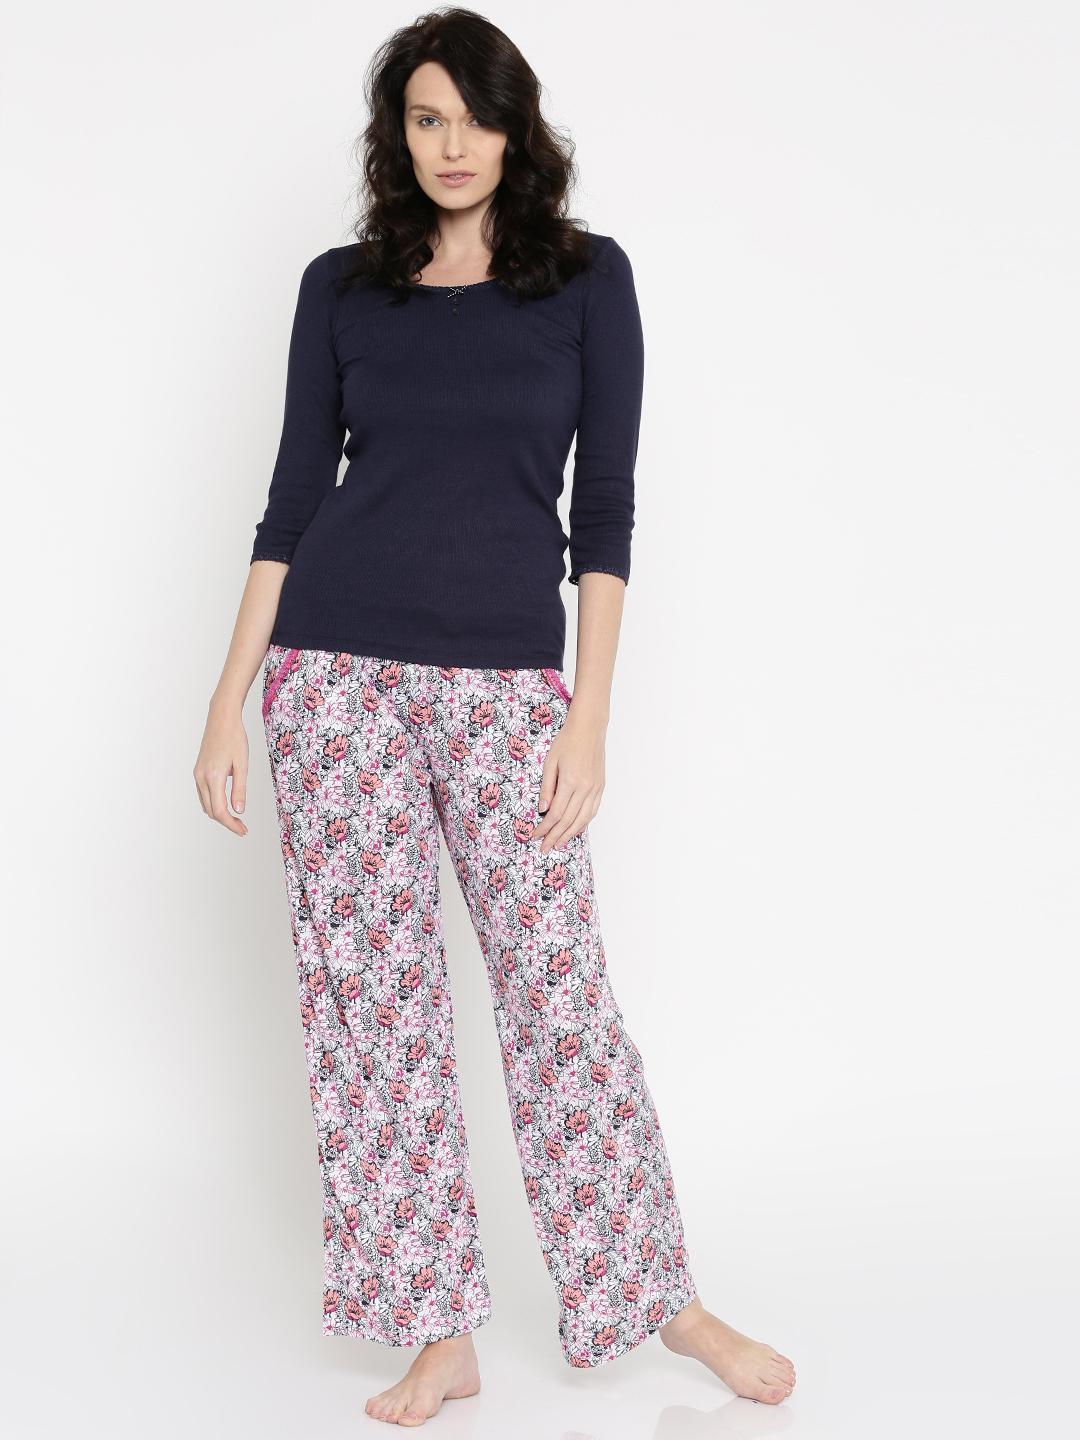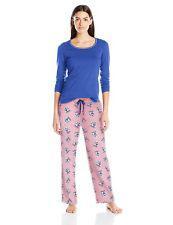The first image is the image on the left, the second image is the image on the right. Analyze the images presented: Is the assertion "There is a woman leaning on her right leg in the left image." valid? Answer yes or no. Yes. The first image is the image on the left, the second image is the image on the right. For the images displayed, is the sentence "There is a person with one arm raised so that that hand is approximately level with their shoulder." factually correct? Answer yes or no. No. 